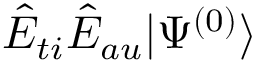Convert formula to latex. <formula><loc_0><loc_0><loc_500><loc_500>\hat { E } _ { t i } \hat { E } _ { a u } | \Psi ^ { ( 0 ) } \rangle</formula> 